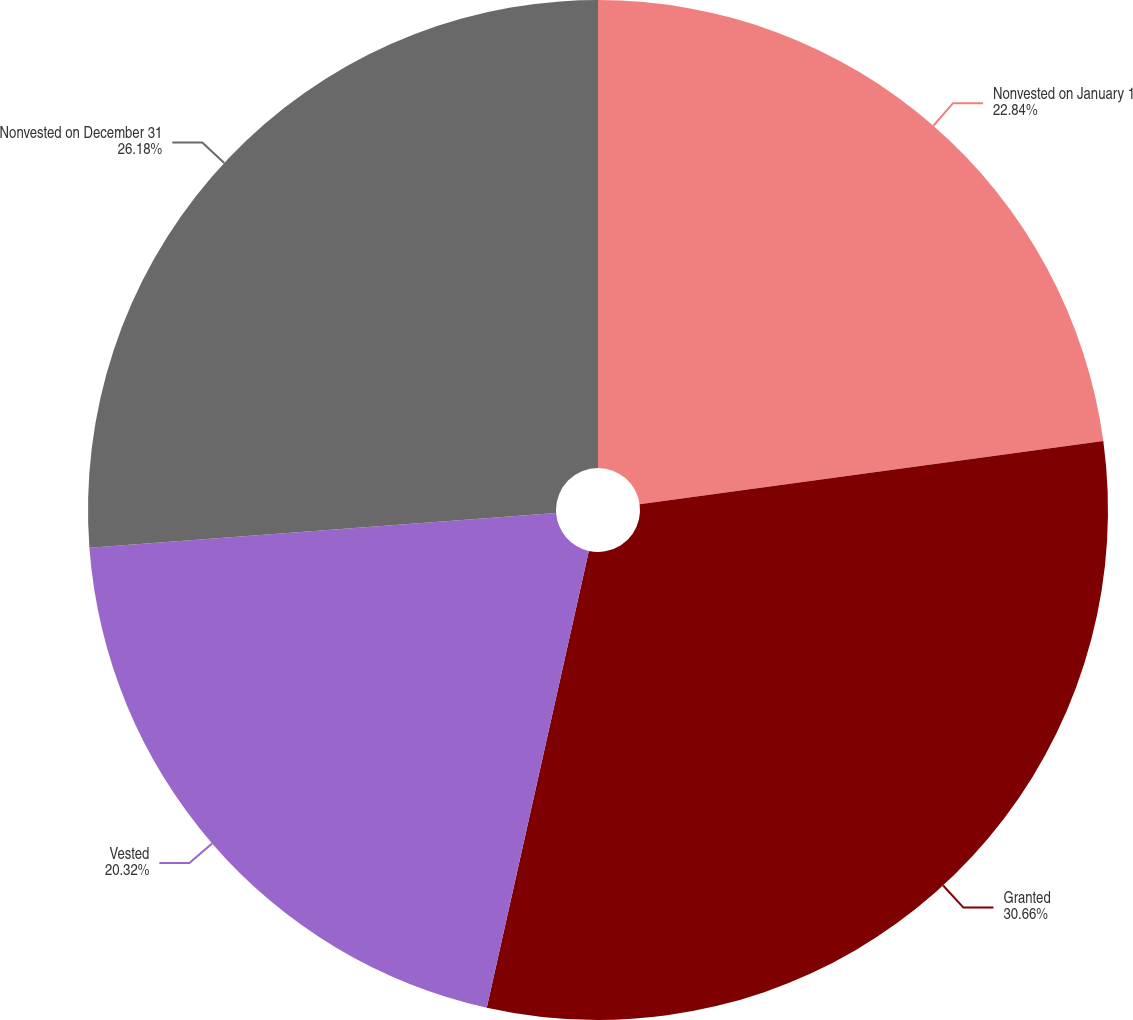Convert chart. <chart><loc_0><loc_0><loc_500><loc_500><pie_chart><fcel>Nonvested on January 1<fcel>Granted<fcel>Vested<fcel>Nonvested on December 31<nl><fcel>22.84%<fcel>30.66%<fcel>20.32%<fcel>26.18%<nl></chart> 